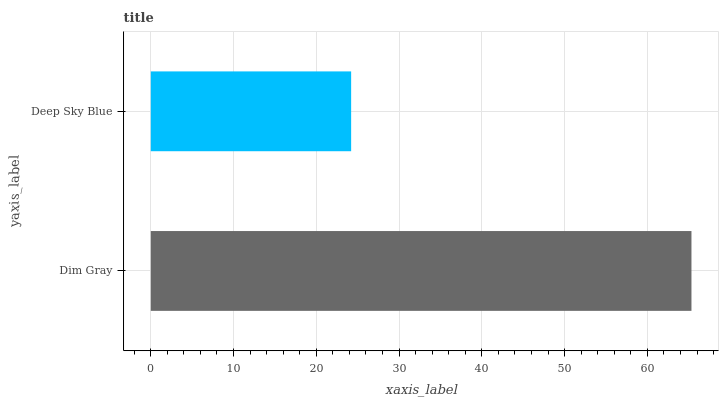Is Deep Sky Blue the minimum?
Answer yes or no. Yes. Is Dim Gray the maximum?
Answer yes or no. Yes. Is Deep Sky Blue the maximum?
Answer yes or no. No. Is Dim Gray greater than Deep Sky Blue?
Answer yes or no. Yes. Is Deep Sky Blue less than Dim Gray?
Answer yes or no. Yes. Is Deep Sky Blue greater than Dim Gray?
Answer yes or no. No. Is Dim Gray less than Deep Sky Blue?
Answer yes or no. No. Is Dim Gray the high median?
Answer yes or no. Yes. Is Deep Sky Blue the low median?
Answer yes or no. Yes. Is Deep Sky Blue the high median?
Answer yes or no. No. Is Dim Gray the low median?
Answer yes or no. No. 